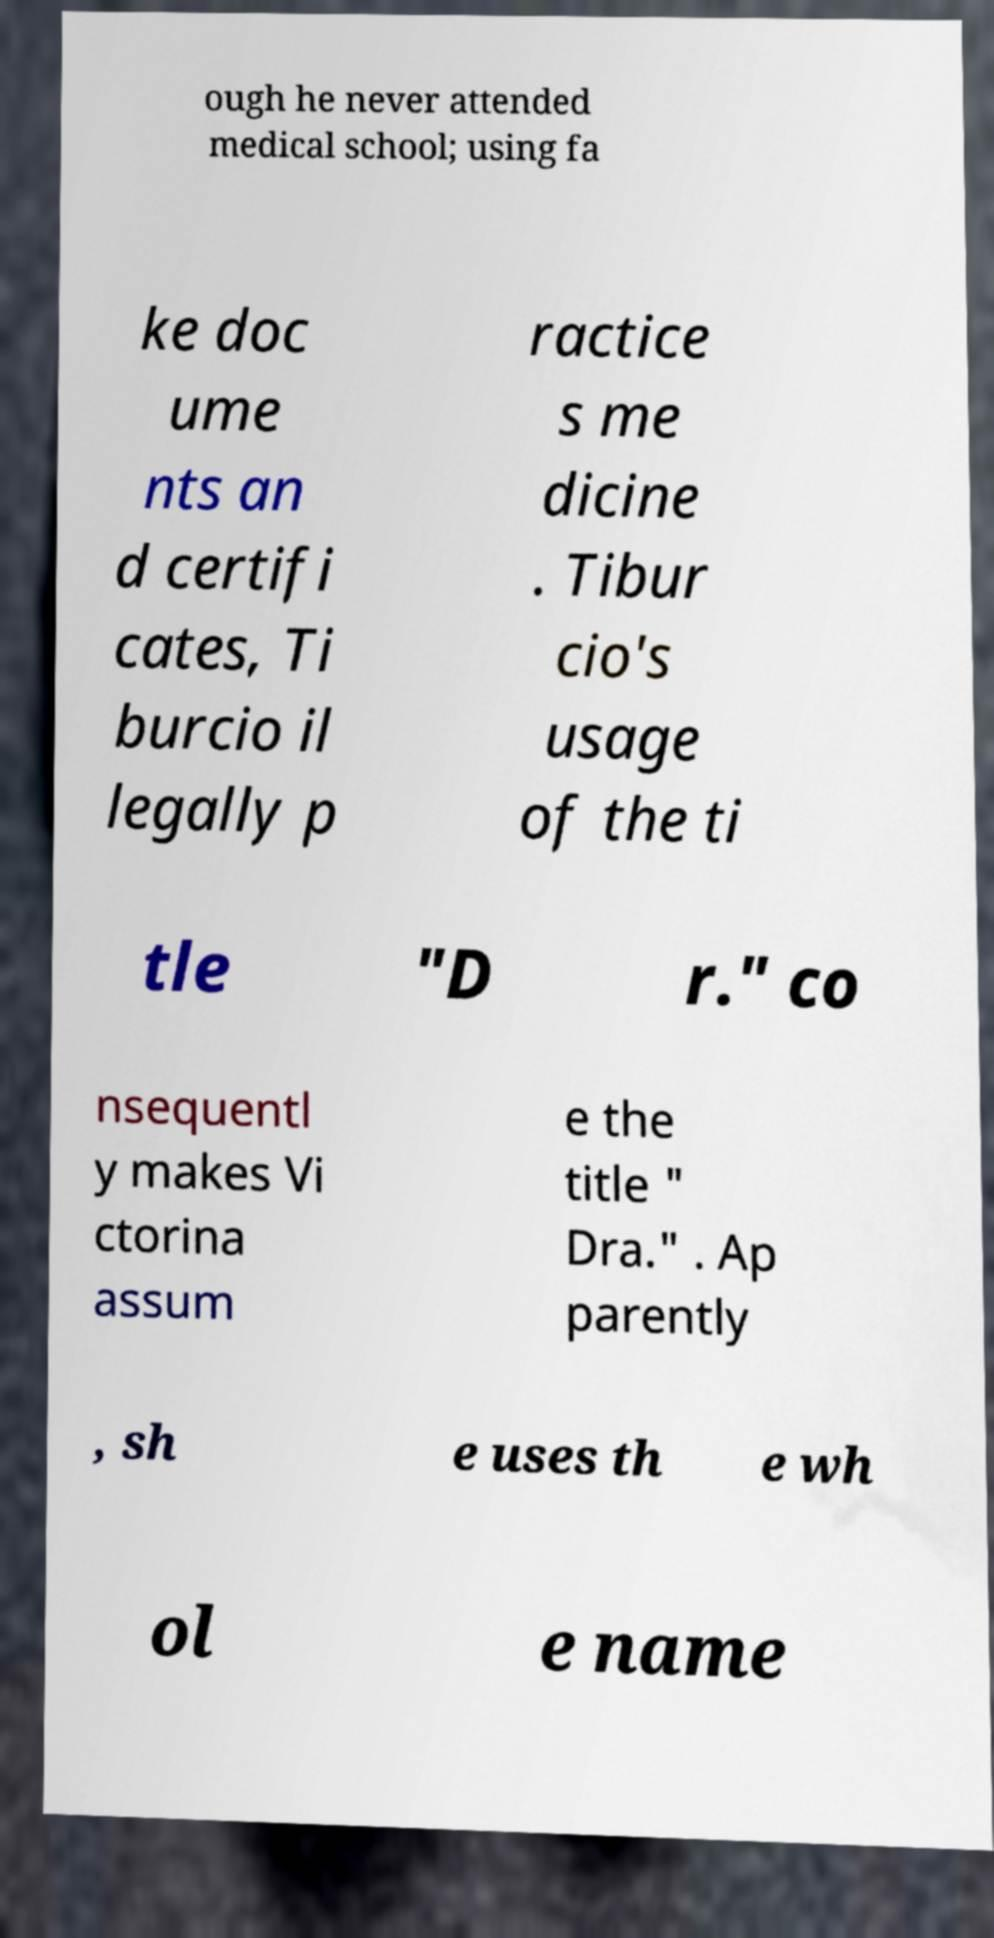Please identify and transcribe the text found in this image. ough he never attended medical school; using fa ke doc ume nts an d certifi cates, Ti burcio il legally p ractice s me dicine . Tibur cio's usage of the ti tle "D r." co nsequentl y makes Vi ctorina assum e the title " Dra." . Ap parently , sh e uses th e wh ol e name 